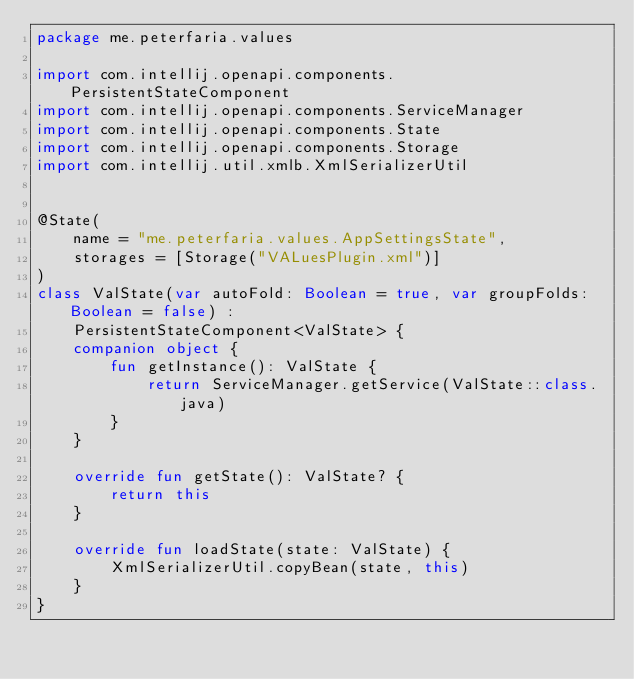<code> <loc_0><loc_0><loc_500><loc_500><_Kotlin_>package me.peterfaria.values

import com.intellij.openapi.components.PersistentStateComponent
import com.intellij.openapi.components.ServiceManager
import com.intellij.openapi.components.State
import com.intellij.openapi.components.Storage
import com.intellij.util.xmlb.XmlSerializerUtil


@State(
    name = "me.peterfaria.values.AppSettingsState",
    storages = [Storage("VALuesPlugin.xml")]
)
class ValState(var autoFold: Boolean = true, var groupFolds: Boolean = false) :
    PersistentStateComponent<ValState> {
    companion object {
        fun getInstance(): ValState {
            return ServiceManager.getService(ValState::class.java)
        }
    }

    override fun getState(): ValState? {
        return this
    }

    override fun loadState(state: ValState) {
        XmlSerializerUtil.copyBean(state, this)
    }
}</code> 